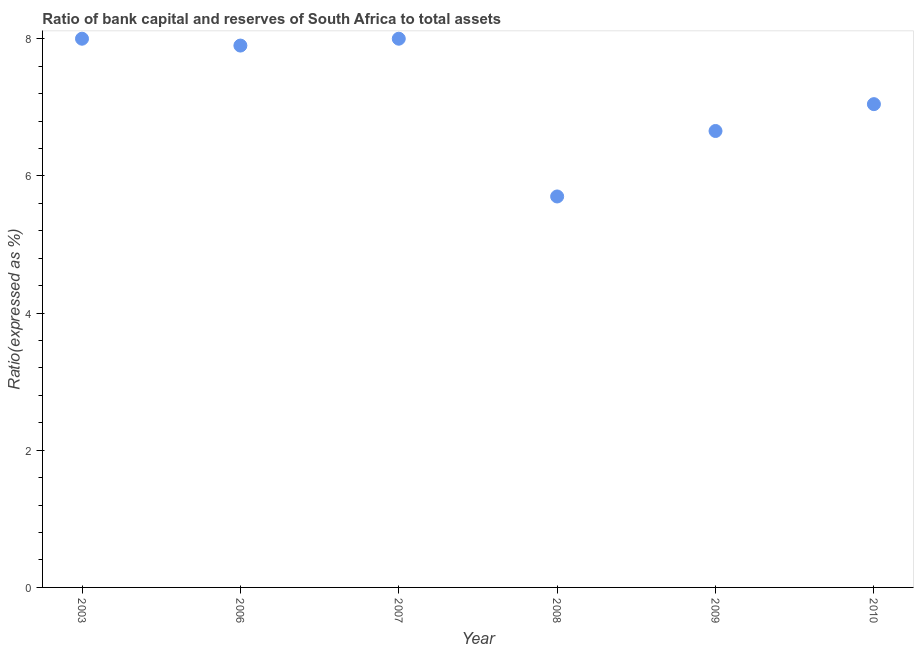In which year was the bank capital to assets ratio maximum?
Keep it short and to the point. 2003. In which year was the bank capital to assets ratio minimum?
Offer a very short reply. 2008. What is the sum of the bank capital to assets ratio?
Offer a very short reply. 43.3. What is the difference between the bank capital to assets ratio in 2007 and 2010?
Provide a short and direct response. 0.95. What is the average bank capital to assets ratio per year?
Provide a succinct answer. 7.22. What is the median bank capital to assets ratio?
Provide a short and direct response. 7.47. What is the ratio of the bank capital to assets ratio in 2007 to that in 2008?
Your response must be concise. 1.4. Is the difference between the bank capital to assets ratio in 2007 and 2010 greater than the difference between any two years?
Make the answer very short. No. What is the difference between the highest and the second highest bank capital to assets ratio?
Give a very brief answer. 0. Does the bank capital to assets ratio monotonically increase over the years?
Keep it short and to the point. No. How many dotlines are there?
Give a very brief answer. 1. How many years are there in the graph?
Provide a short and direct response. 6. What is the difference between two consecutive major ticks on the Y-axis?
Offer a terse response. 2. Are the values on the major ticks of Y-axis written in scientific E-notation?
Your answer should be compact. No. Does the graph contain grids?
Ensure brevity in your answer.  No. What is the title of the graph?
Offer a terse response. Ratio of bank capital and reserves of South Africa to total assets. What is the label or title of the X-axis?
Provide a succinct answer. Year. What is the label or title of the Y-axis?
Keep it short and to the point. Ratio(expressed as %). What is the Ratio(expressed as %) in 2003?
Your answer should be compact. 8. What is the Ratio(expressed as %) in 2006?
Your answer should be very brief. 7.9. What is the Ratio(expressed as %) in 2007?
Keep it short and to the point. 8. What is the Ratio(expressed as %) in 2008?
Give a very brief answer. 5.7. What is the Ratio(expressed as %) in 2009?
Provide a succinct answer. 6.65. What is the Ratio(expressed as %) in 2010?
Ensure brevity in your answer.  7.05. What is the difference between the Ratio(expressed as %) in 2003 and 2006?
Ensure brevity in your answer.  0.1. What is the difference between the Ratio(expressed as %) in 2003 and 2007?
Make the answer very short. 0. What is the difference between the Ratio(expressed as %) in 2003 and 2008?
Give a very brief answer. 2.3. What is the difference between the Ratio(expressed as %) in 2003 and 2009?
Your answer should be compact. 1.35. What is the difference between the Ratio(expressed as %) in 2003 and 2010?
Your answer should be compact. 0.95. What is the difference between the Ratio(expressed as %) in 2006 and 2007?
Make the answer very short. -0.1. What is the difference between the Ratio(expressed as %) in 2006 and 2008?
Give a very brief answer. 2.2. What is the difference between the Ratio(expressed as %) in 2006 and 2009?
Provide a succinct answer. 1.25. What is the difference between the Ratio(expressed as %) in 2006 and 2010?
Provide a short and direct response. 0.85. What is the difference between the Ratio(expressed as %) in 2007 and 2009?
Your answer should be very brief. 1.35. What is the difference between the Ratio(expressed as %) in 2007 and 2010?
Offer a very short reply. 0.95. What is the difference between the Ratio(expressed as %) in 2008 and 2009?
Provide a short and direct response. -0.95. What is the difference between the Ratio(expressed as %) in 2008 and 2010?
Ensure brevity in your answer.  -1.35. What is the difference between the Ratio(expressed as %) in 2009 and 2010?
Provide a succinct answer. -0.39. What is the ratio of the Ratio(expressed as %) in 2003 to that in 2008?
Offer a very short reply. 1.4. What is the ratio of the Ratio(expressed as %) in 2003 to that in 2009?
Your answer should be very brief. 1.2. What is the ratio of the Ratio(expressed as %) in 2003 to that in 2010?
Your answer should be very brief. 1.14. What is the ratio of the Ratio(expressed as %) in 2006 to that in 2007?
Ensure brevity in your answer.  0.99. What is the ratio of the Ratio(expressed as %) in 2006 to that in 2008?
Give a very brief answer. 1.39. What is the ratio of the Ratio(expressed as %) in 2006 to that in 2009?
Provide a succinct answer. 1.19. What is the ratio of the Ratio(expressed as %) in 2006 to that in 2010?
Give a very brief answer. 1.12. What is the ratio of the Ratio(expressed as %) in 2007 to that in 2008?
Your response must be concise. 1.4. What is the ratio of the Ratio(expressed as %) in 2007 to that in 2009?
Make the answer very short. 1.2. What is the ratio of the Ratio(expressed as %) in 2007 to that in 2010?
Keep it short and to the point. 1.14. What is the ratio of the Ratio(expressed as %) in 2008 to that in 2009?
Offer a very short reply. 0.86. What is the ratio of the Ratio(expressed as %) in 2008 to that in 2010?
Make the answer very short. 0.81. What is the ratio of the Ratio(expressed as %) in 2009 to that in 2010?
Your response must be concise. 0.94. 